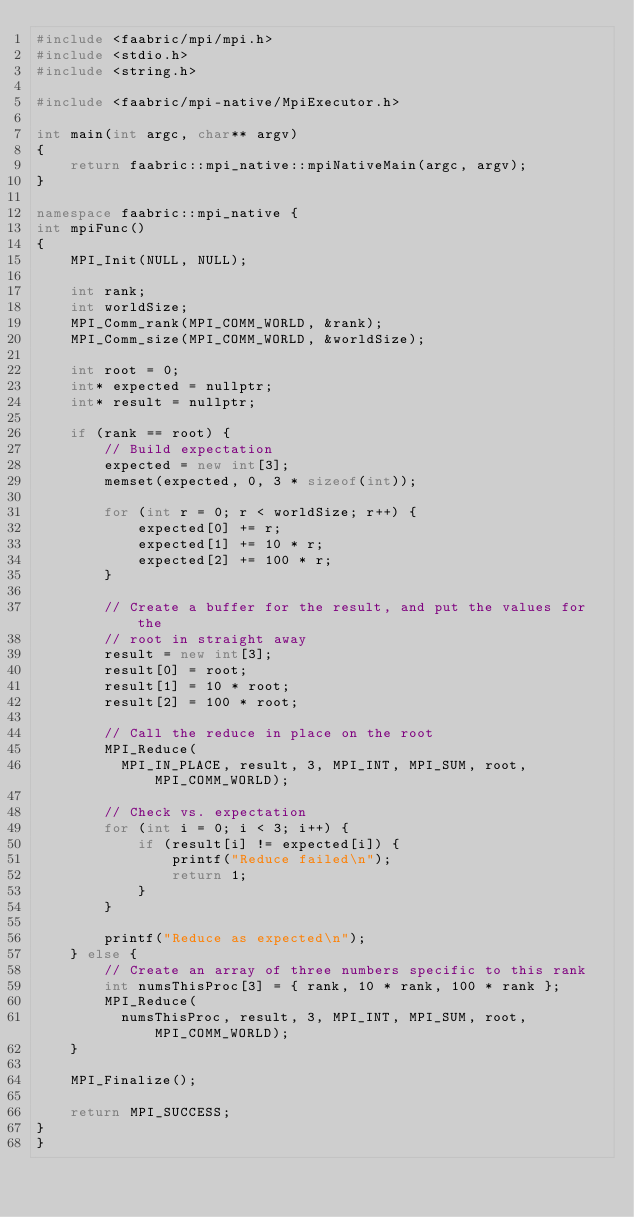<code> <loc_0><loc_0><loc_500><loc_500><_C++_>#include <faabric/mpi/mpi.h>
#include <stdio.h>
#include <string.h>

#include <faabric/mpi-native/MpiExecutor.h>

int main(int argc, char** argv)
{
    return faabric::mpi_native::mpiNativeMain(argc, argv);
}

namespace faabric::mpi_native {
int mpiFunc()
{
    MPI_Init(NULL, NULL);

    int rank;
    int worldSize;
    MPI_Comm_rank(MPI_COMM_WORLD, &rank);
    MPI_Comm_size(MPI_COMM_WORLD, &worldSize);

    int root = 0;
    int* expected = nullptr;
    int* result = nullptr;

    if (rank == root) {
        // Build expectation
        expected = new int[3];
        memset(expected, 0, 3 * sizeof(int));

        for (int r = 0; r < worldSize; r++) {
            expected[0] += r;
            expected[1] += 10 * r;
            expected[2] += 100 * r;
        }

        // Create a buffer for the result, and put the values for the
        // root in straight away
        result = new int[3];
        result[0] = root;
        result[1] = 10 * root;
        result[2] = 100 * root;

        // Call the reduce in place on the root
        MPI_Reduce(
          MPI_IN_PLACE, result, 3, MPI_INT, MPI_SUM, root, MPI_COMM_WORLD);

        // Check vs. expectation
        for (int i = 0; i < 3; i++) {
            if (result[i] != expected[i]) {
                printf("Reduce failed\n");
                return 1;
            }
        }

        printf("Reduce as expected\n");
    } else {
        // Create an array of three numbers specific to this rank
        int numsThisProc[3] = { rank, 10 * rank, 100 * rank };
        MPI_Reduce(
          numsThisProc, result, 3, MPI_INT, MPI_SUM, root, MPI_COMM_WORLD);
    }

    MPI_Finalize();

    return MPI_SUCCESS;
}
}
</code> 